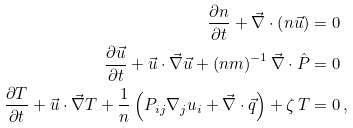Convert formula to latex. <formula><loc_0><loc_0><loc_500><loc_500>\frac { \partial n } { \partial t } + \vec { \nabla } \cdot \left ( n \vec { u } \right ) & = 0 \\ \frac { \partial \vec { u } } { \partial t } + \vec { u } \cdot \vec { \nabla } \vec { u } + \left ( n m \right ) ^ { - 1 } \vec { \nabla } \cdot \hat { P } & = 0 \\ \frac { \partial T } { \partial t } + \vec { u } \cdot \vec { \nabla } T + \frac { 1 } { n } \left ( P _ { i j } \nabla _ { j } u _ { i } + \vec { \nabla } \cdot \vec { q } \right ) + \zeta \, T & = 0 \, ,</formula> 